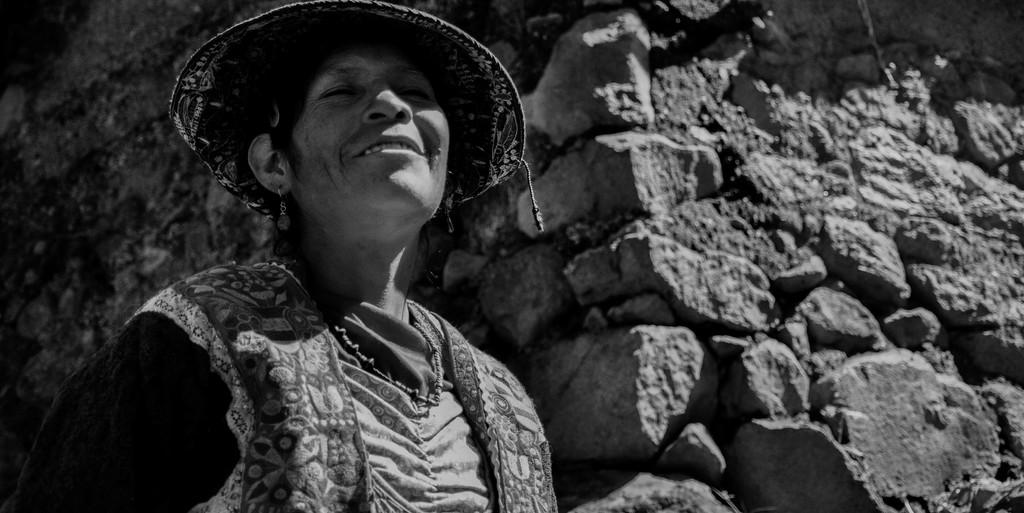What is the color scheme of the image? The image is black and white. What can be seen in the foreground of the image? There is a woman standing in the image. What is the woman wearing on her head? The woman is wearing a hat. What is visible in the background of the image? There is a wall in the background of the image. What type of sand can be seen on the woman's voyage in the image? There is no reference to a voyage or sand in the image; it features a woman standing in a black and white setting. 